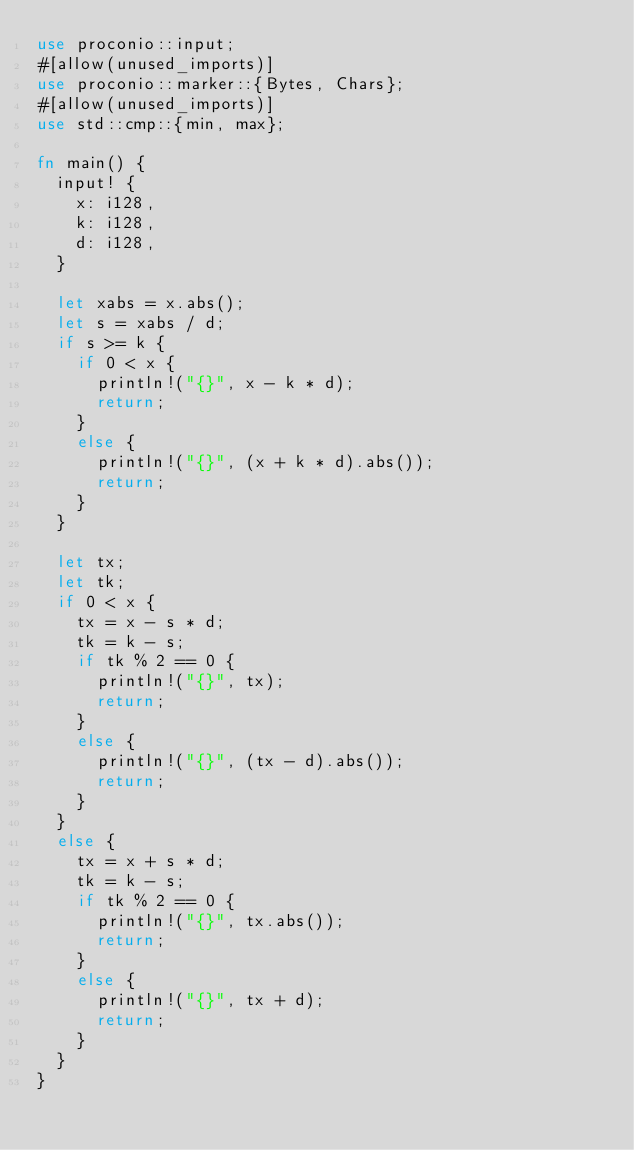Convert code to text. <code><loc_0><loc_0><loc_500><loc_500><_Rust_>use proconio::input;
#[allow(unused_imports)]
use proconio::marker::{Bytes, Chars};
#[allow(unused_imports)]
use std::cmp::{min, max};
 
fn main() {
	input! {
		x: i128,
		k: i128,
		d: i128,
	}
 
	let xabs = x.abs();
	let s = xabs / d;
	if s >= k {
		if 0 < x {
			println!("{}", x - k * d);
			return;
		}
		else {
			println!("{}", (x + k * d).abs());
			return;
		}
	}
 
	let tx;
	let tk;
	if 0 < x {
		tx = x - s * d;
		tk = k - s;
		if tk % 2 == 0 {
			println!("{}", tx);
			return;
		}
		else {
			println!("{}", (tx - d).abs());
			return;
		}
	}
	else {
		tx = x + s * d;
		tk = k - s;
		if tk % 2 == 0 {
			println!("{}", tx.abs());
			return;
		}
		else {
			println!("{}", tx + d);
			return;
		}
	}
}
</code> 